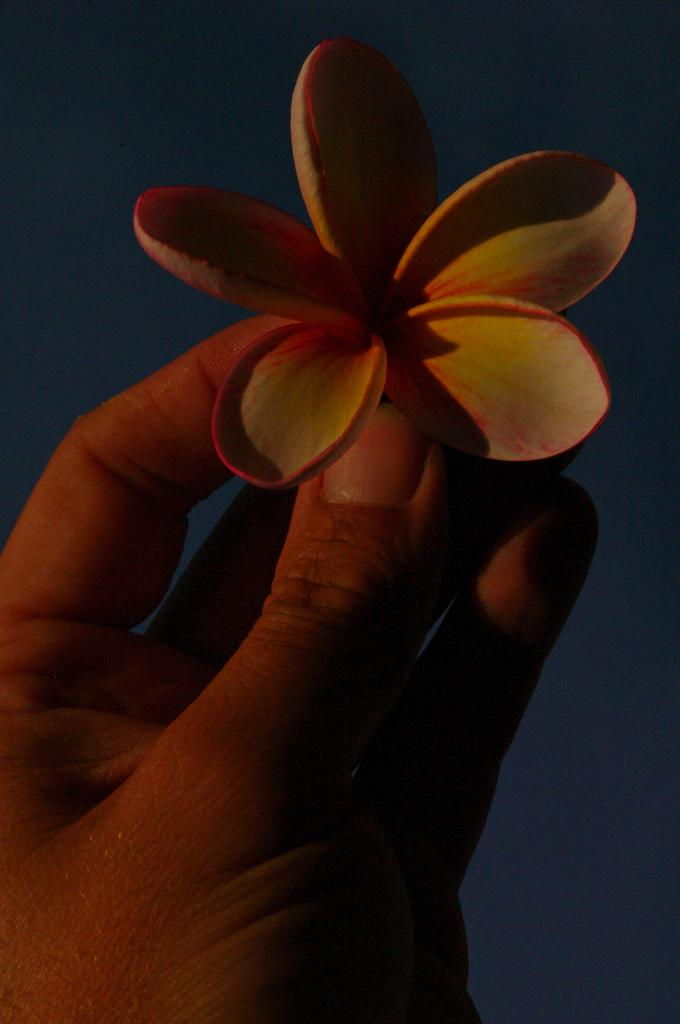What can be seen in the image? There is a person's hand in the image. What is the hand holding? The hand is holding a flower. What is the writing on the flower in the image? There is no writing on the flower in the image. The image only shows a person's hand holding a flower. 